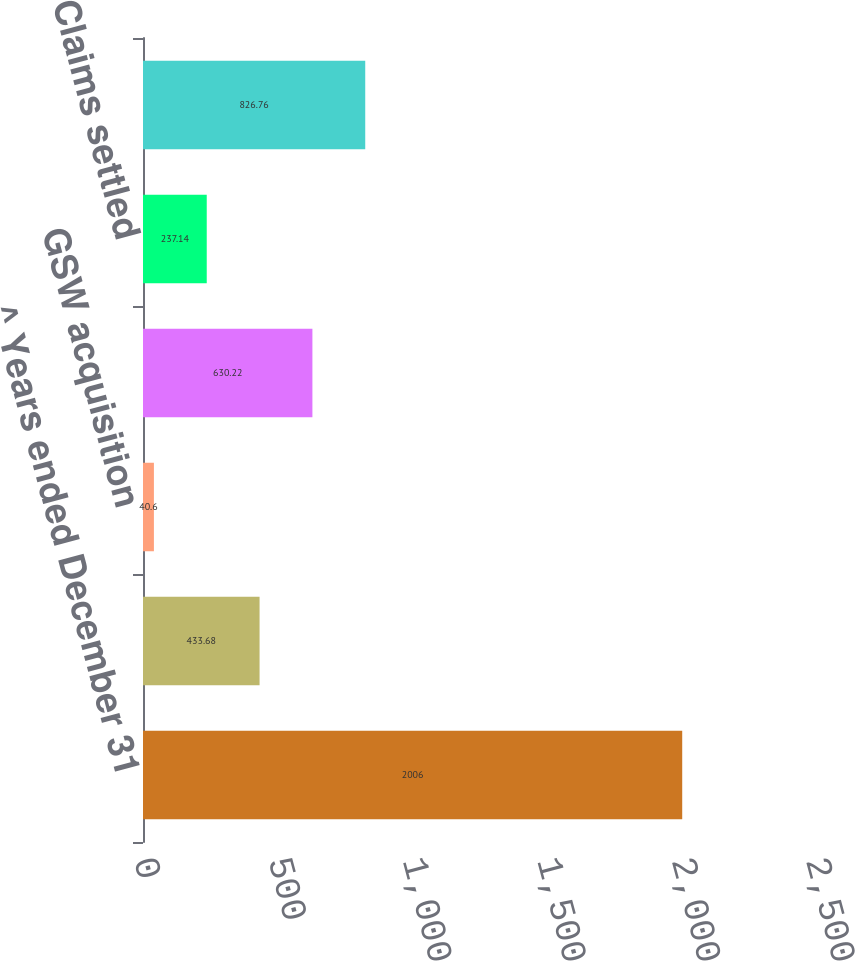Convert chart to OTSL. <chart><loc_0><loc_0><loc_500><loc_500><bar_chart><fcel>^ Years ended December 31<fcel>Balance at beginning of year<fcel>GSW acquisition<fcel>Expense<fcel>Claims settled<fcel>Balance at end of year<nl><fcel>2006<fcel>433.68<fcel>40.6<fcel>630.22<fcel>237.14<fcel>826.76<nl></chart> 